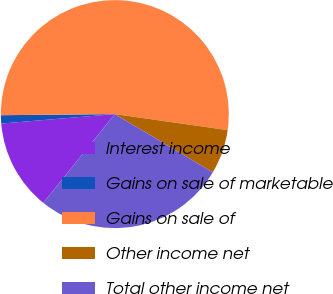Convert chart to OTSL. <chart><loc_0><loc_0><loc_500><loc_500><pie_chart><fcel>Interest income<fcel>Gains on sale of marketable<fcel>Gains on sale of<fcel>Other income net<fcel>Total other income net<nl><fcel>12.88%<fcel>1.17%<fcel>52.4%<fcel>6.29%<fcel>27.26%<nl></chart> 